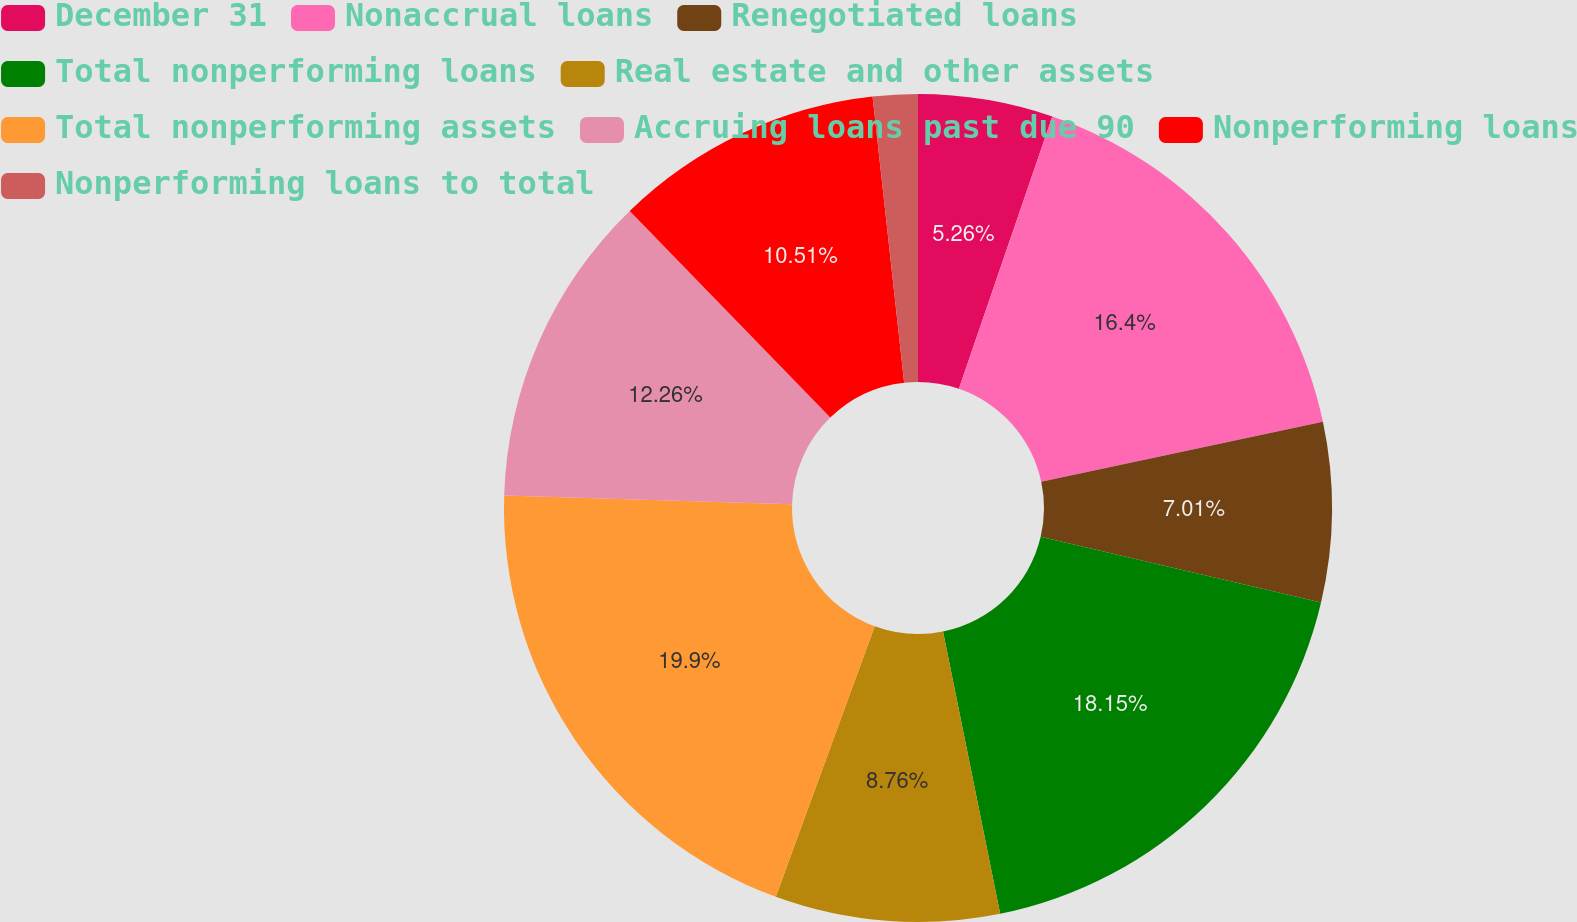Convert chart. <chart><loc_0><loc_0><loc_500><loc_500><pie_chart><fcel>December 31<fcel>Nonaccrual loans<fcel>Renegotiated loans<fcel>Total nonperforming loans<fcel>Real estate and other assets<fcel>Total nonperforming assets<fcel>Accruing loans past due 90<fcel>Nonperforming loans<fcel>Nonperforming loans to total<nl><fcel>5.26%<fcel>16.4%<fcel>7.01%<fcel>18.15%<fcel>8.76%<fcel>19.9%<fcel>12.26%<fcel>10.51%<fcel>1.75%<nl></chart> 